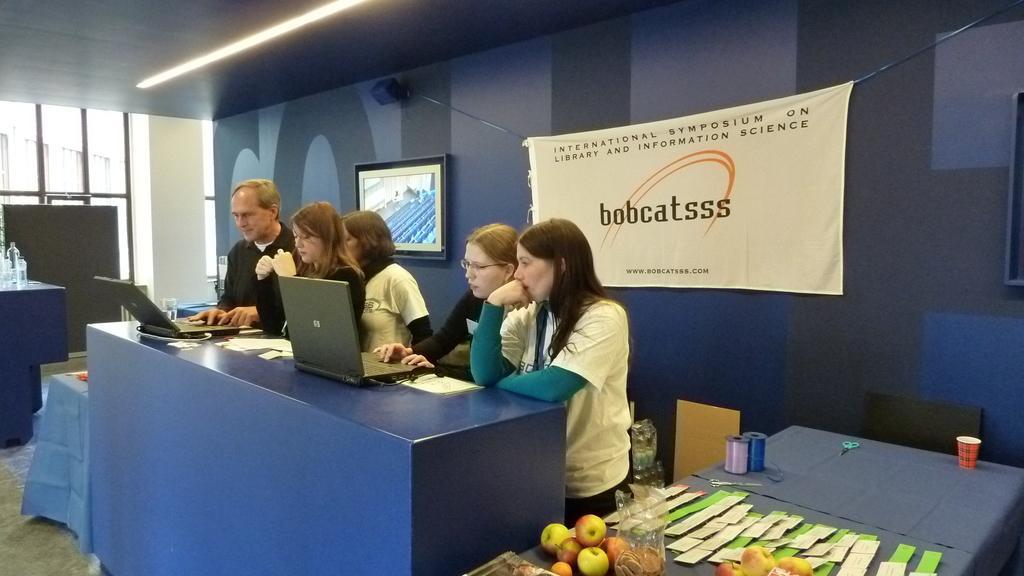How would you summarize this image in a sentence or two? Here we see a group of people standing and using laptops on the table and we see some fruits and a banner on the back.
and a television on the wall. 